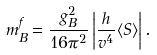<formula> <loc_0><loc_0><loc_500><loc_500>m _ { B } ^ { f } = \frac { g _ { B } ^ { 2 } } { 1 6 \pi ^ { 2 } } \left | \frac { h } { v ^ { 4 } } \langle S \rangle \right | .</formula> 